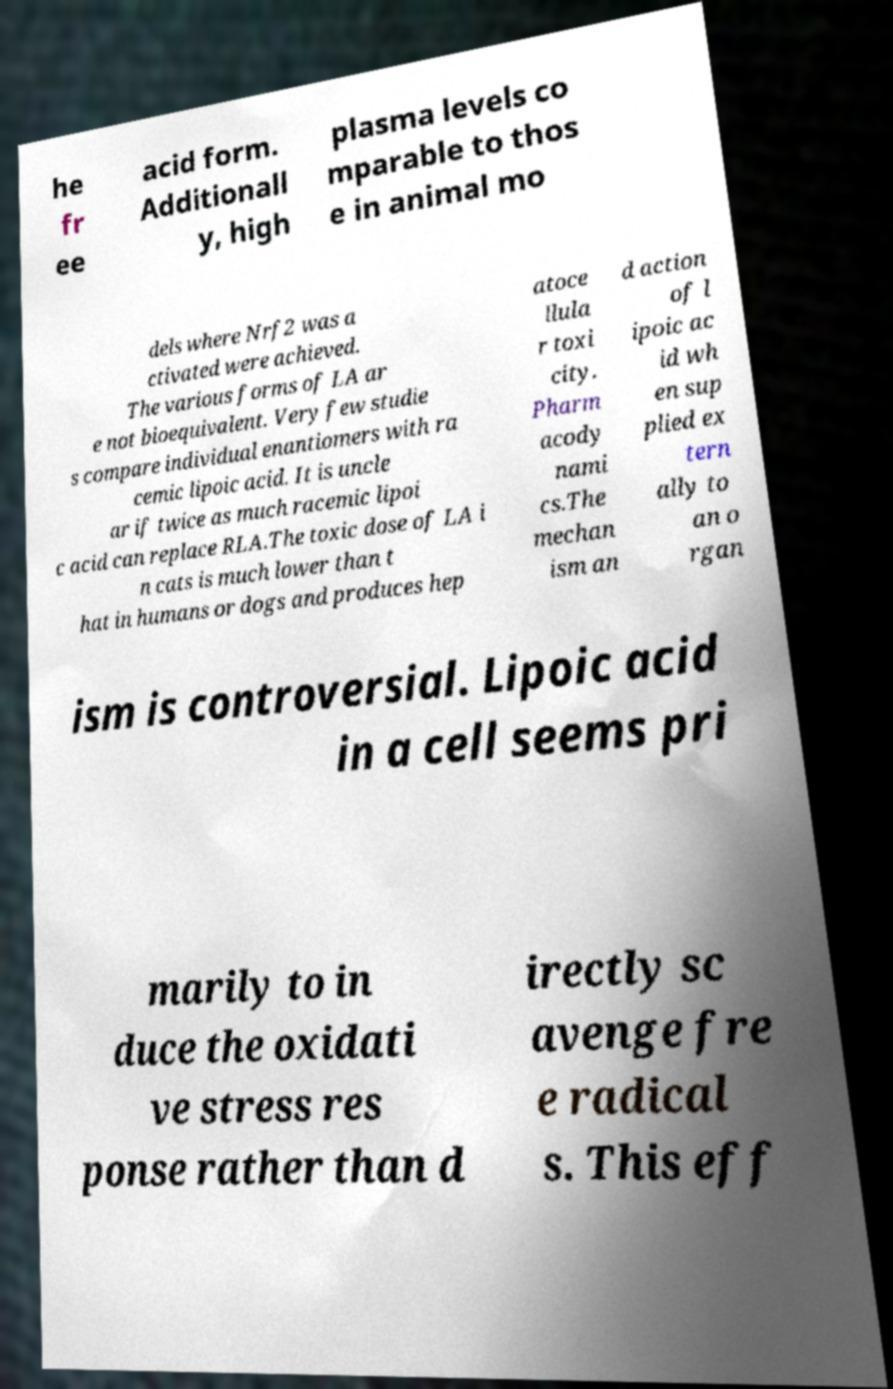Could you assist in decoding the text presented in this image and type it out clearly? he fr ee acid form. Additionall y, high plasma levels co mparable to thos e in animal mo dels where Nrf2 was a ctivated were achieved. The various forms of LA ar e not bioequivalent. Very few studie s compare individual enantiomers with ra cemic lipoic acid. It is uncle ar if twice as much racemic lipoi c acid can replace RLA.The toxic dose of LA i n cats is much lower than t hat in humans or dogs and produces hep atoce llula r toxi city. Pharm acody nami cs.The mechan ism an d action of l ipoic ac id wh en sup plied ex tern ally to an o rgan ism is controversial. Lipoic acid in a cell seems pri marily to in duce the oxidati ve stress res ponse rather than d irectly sc avenge fre e radical s. This eff 